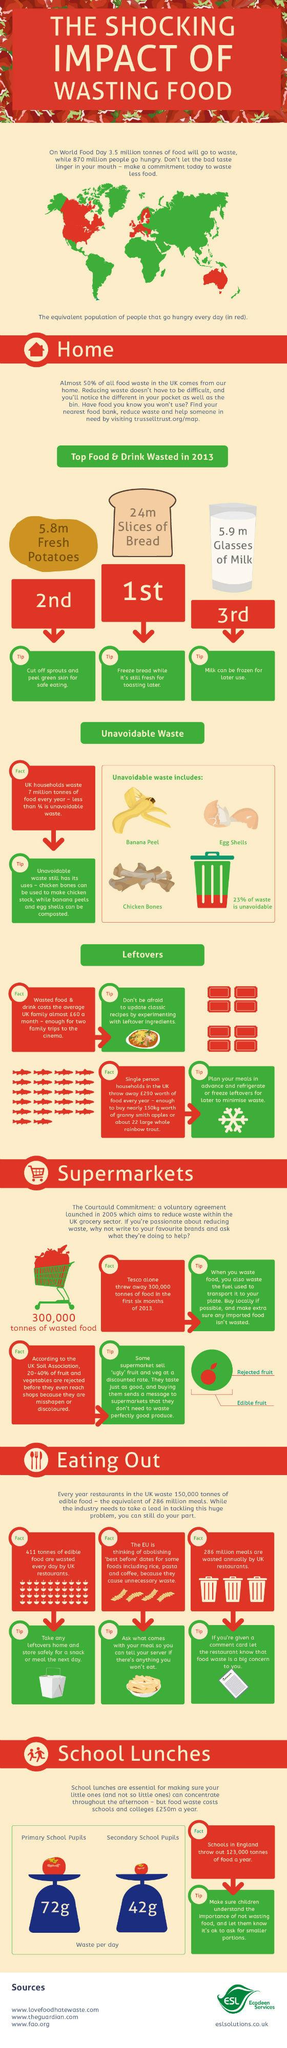List a handful of essential elements in this visual. According to recent estimates, secondary school pupils in the UK waste an average of 42 grams of food per day. In 2013, milk was the top drink that was wasted in the UK. In 2013, bread was the top source of wasted food in the UK. In 2013, it was determined that 77% of waste generated in UK households was avoidable. On average, primary school pupils in the UK waste 72 grams of food per day," according to recent estimates. 